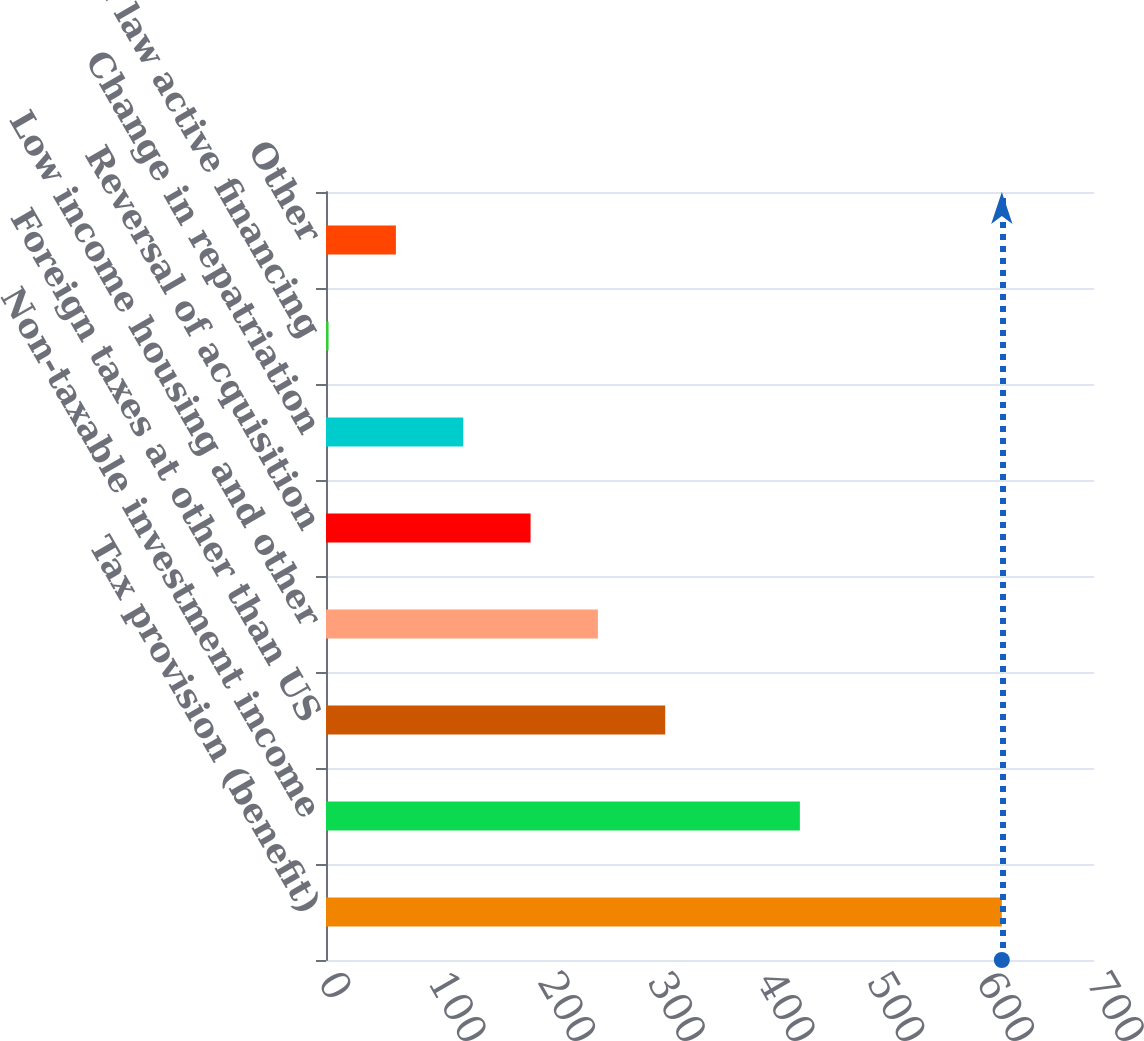Convert chart. <chart><loc_0><loc_0><loc_500><loc_500><bar_chart><fcel>Tax provision (benefit)<fcel>Non-taxable investment income<fcel>Foreign taxes at other than US<fcel>Low income housing and other<fcel>Reversal of acquisition<fcel>Change in repatriation<fcel>Change in law active financing<fcel>Other<nl><fcel>616<fcel>431.93<fcel>309.19<fcel>247.82<fcel>186.45<fcel>125.08<fcel>2.34<fcel>63.71<nl></chart> 